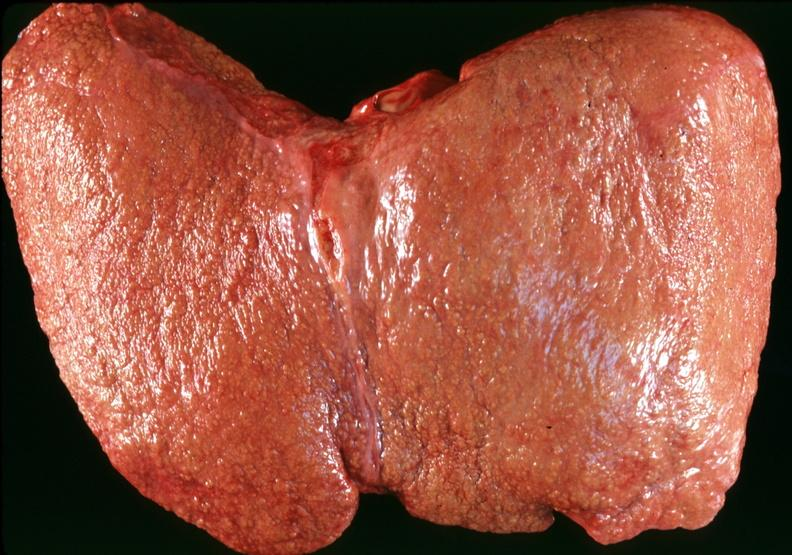what is present?
Answer the question using a single word or phrase. Hepatobiliary 